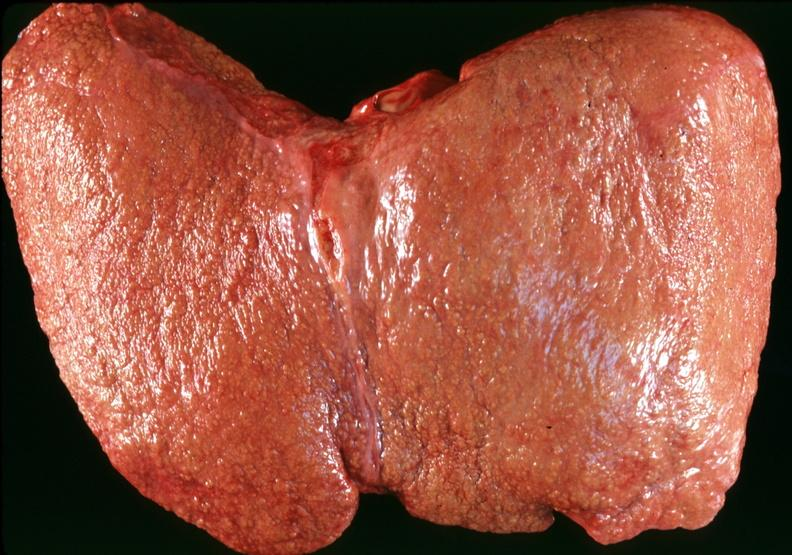what is present?
Answer the question using a single word or phrase. Hepatobiliary 